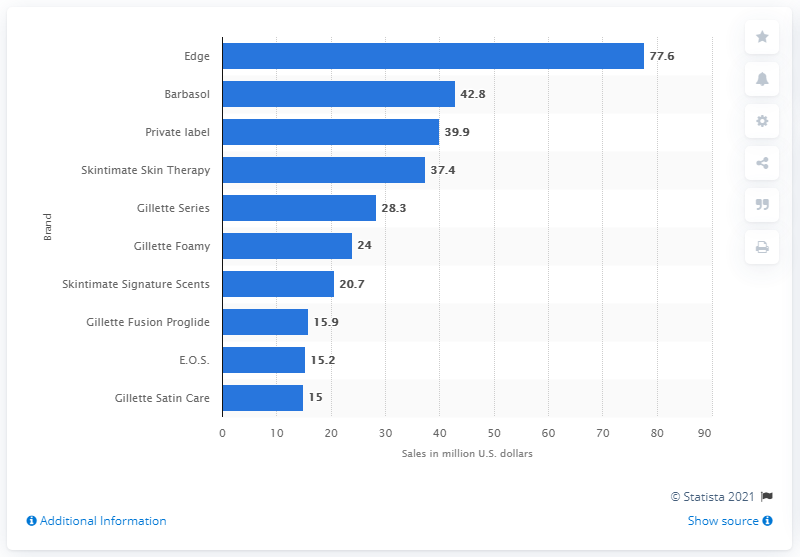Give some essential details in this illustration. In 2019, the amount of money made by Edge in the United States was 77.6 million dollars. In 2019, the leading men's shaving cream brand in the United States was Edge. 